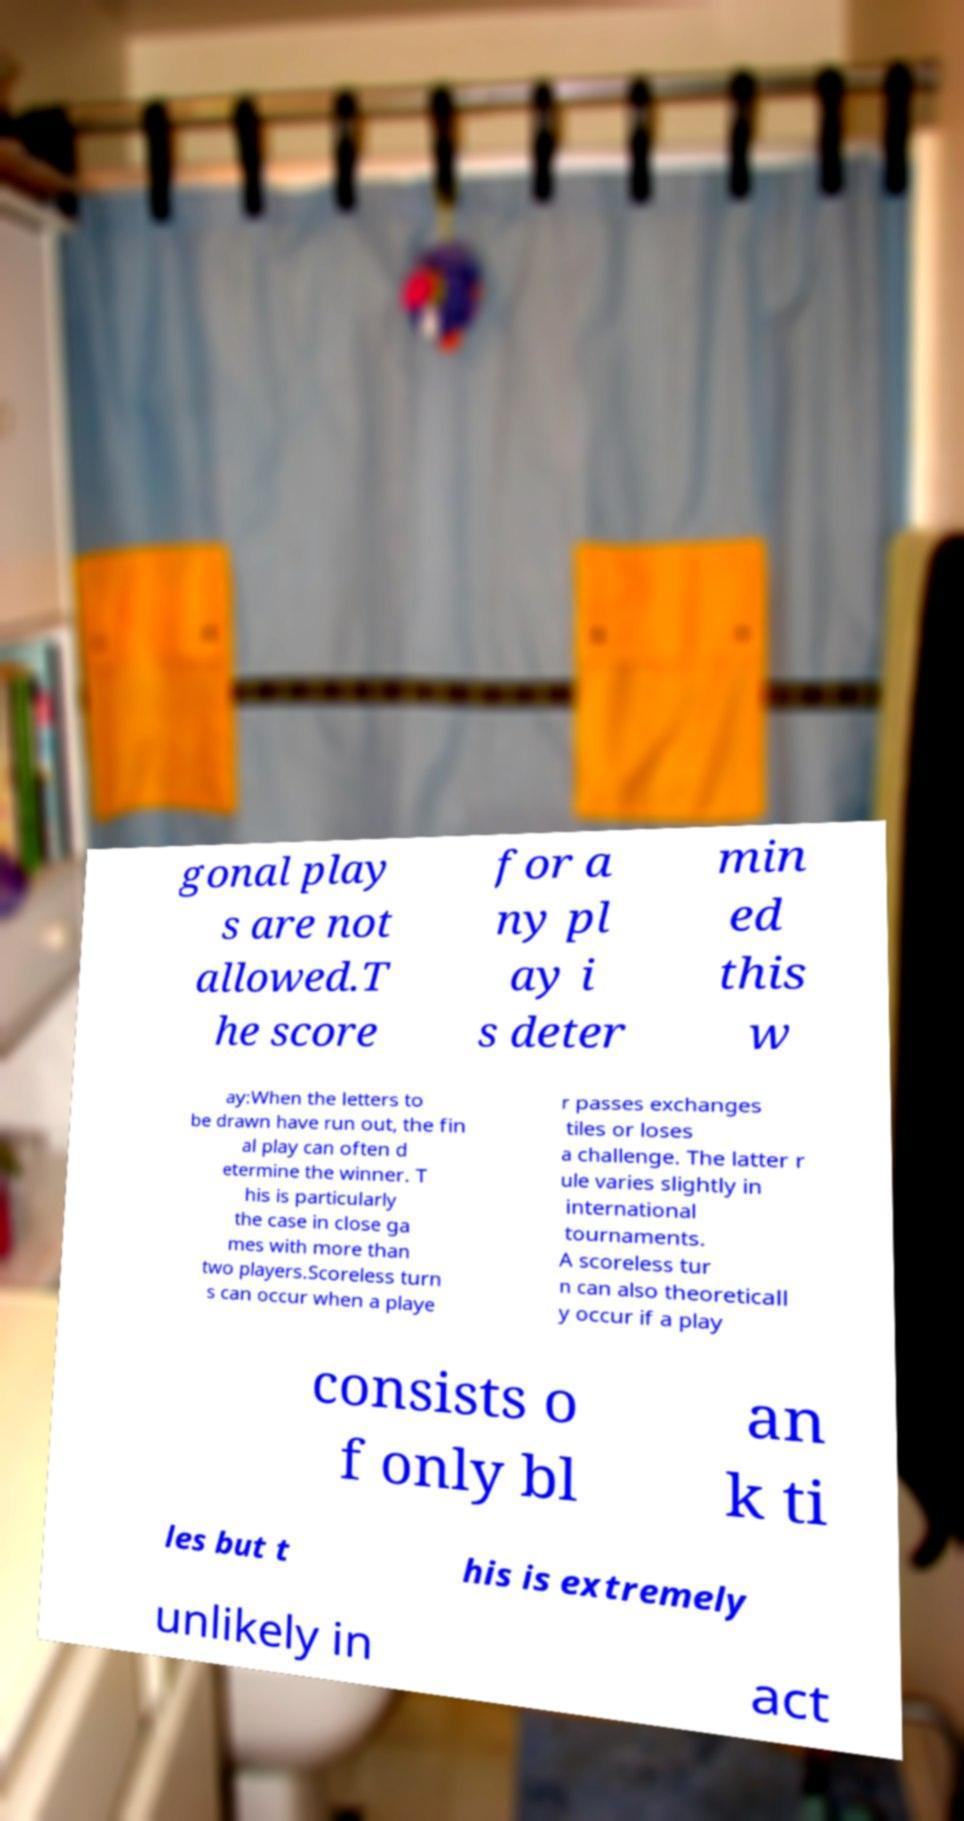What messages or text are displayed in this image? I need them in a readable, typed format. gonal play s are not allowed.T he score for a ny pl ay i s deter min ed this w ay:When the letters to be drawn have run out, the fin al play can often d etermine the winner. T his is particularly the case in close ga mes with more than two players.Scoreless turn s can occur when a playe r passes exchanges tiles or loses a challenge. The latter r ule varies slightly in international tournaments. A scoreless tur n can also theoreticall y occur if a play consists o f only bl an k ti les but t his is extremely unlikely in act 